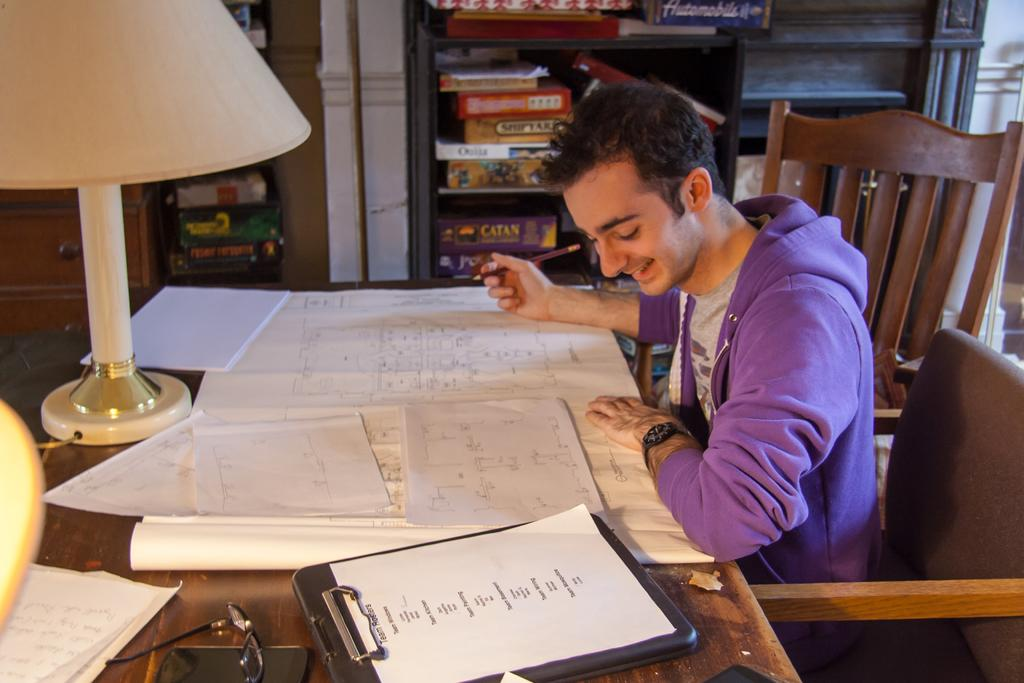Who is in the image? There is a man in the image. What is the man doing in the image? The man is sitting on a chair. What is in front of the man? There is a table in front of the man. What items can be seen on the table? There are papers and a chart on the table. What type of pie is being served to the man in the image? There is no pie present in the image; the table only contains papers and a chart. 